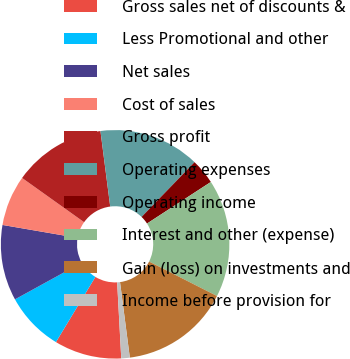Convert chart to OTSL. <chart><loc_0><loc_0><loc_500><loc_500><pie_chart><fcel>Gross sales net of discounts &<fcel>Less Promotional and other<fcel>Net sales<fcel>Cost of sales<fcel>Gross profit<fcel>Operating expenses<fcel>Operating income<fcel>Interest and other (expense)<fcel>Gain (loss) on investments and<fcel>Income before provision for<nl><fcel>9.52%<fcel>8.34%<fcel>10.71%<fcel>7.15%<fcel>13.09%<fcel>14.28%<fcel>3.58%<fcel>16.66%<fcel>15.47%<fcel>1.2%<nl></chart> 